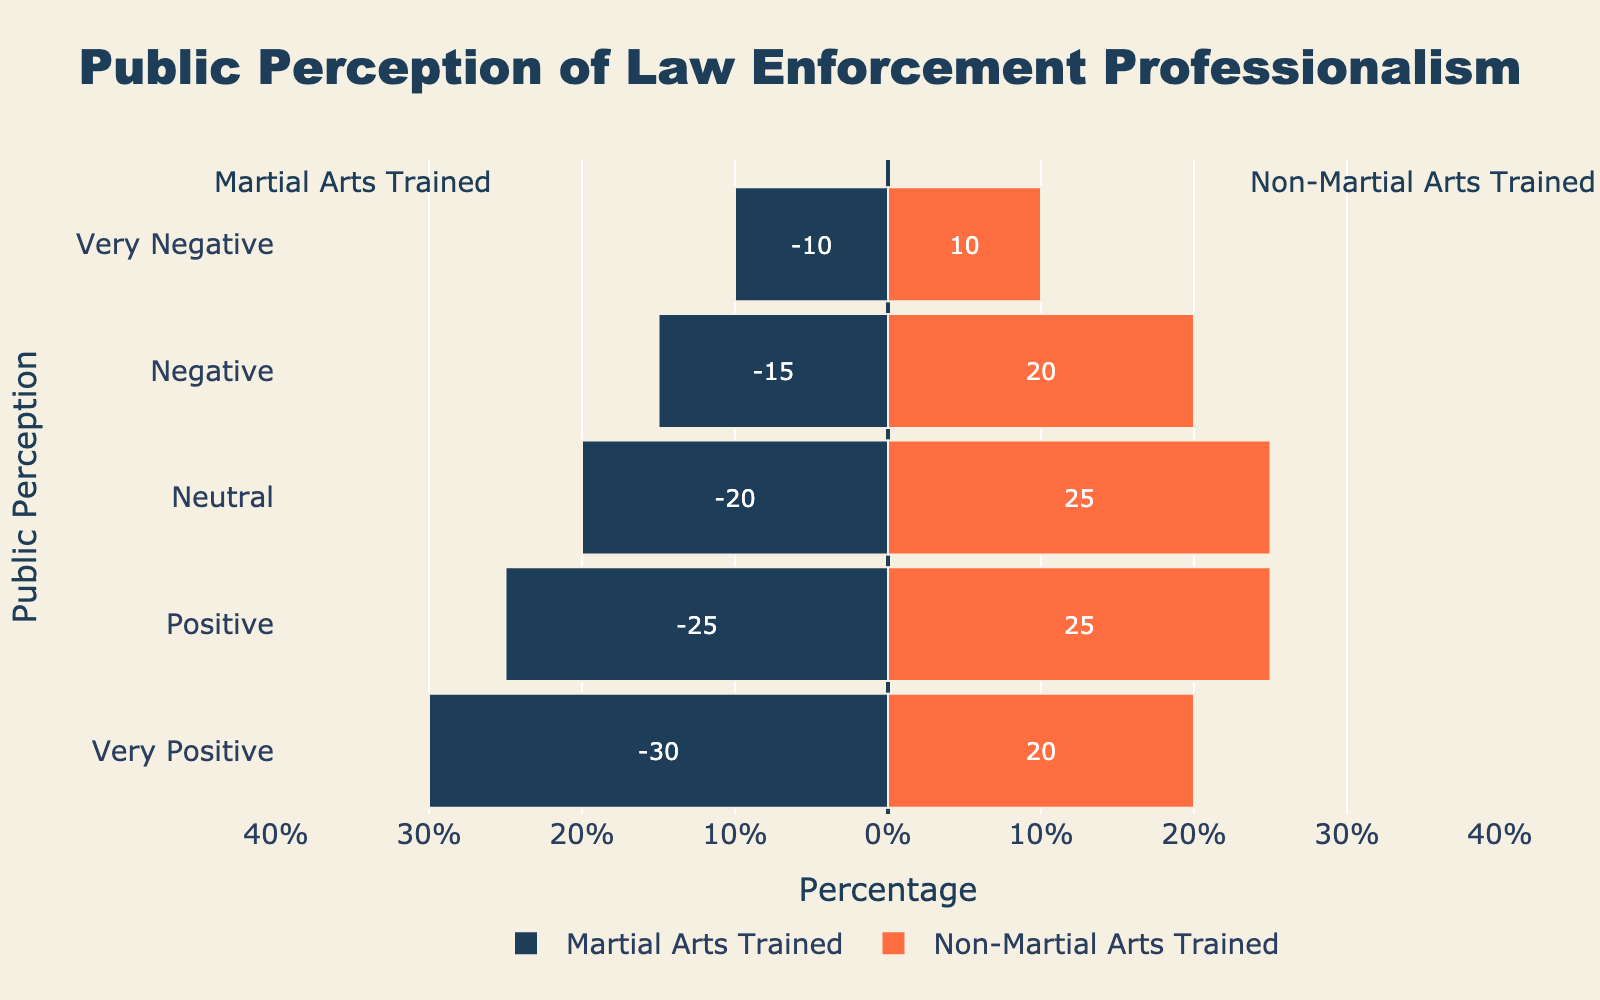What percentage of the public has a very positive perception of martial arts-trained officers? Locate the bar labeled "Very Positive" on the left side representing martial arts-trained officers and read the percentage, which is -30%. The negative sign indicates direction, and the actual percentage is 30%.
Answer: 30% How does the percentage of very positive perceptions compare between martial arts-trained and non-martial arts-trained officers? Compare the "Very Positive" categories. Martial arts-trained officers have 30%, and non-martial arts-trained officers have 20%.
Answer: Martial arts-trained officers have 10% more very positive perceptions What is the total percentage of positive and very positive perceptions for non-martial arts-trained officers? Add the percentages for "Positive" and "Very Positive" for non-martial arts-trained officers. Positive is 25% and Very Positive is 20%, so 25% + 20% = 45%.
Answer: 45% Is the percentage of negative perceptions higher for martial arts-trained officers or non-martial arts-trained officers? Compare the "Negative" categories. Martial arts-trained officers have 15%, and non-martial arts-trained officers have 20%.
Answer: Non-martial arts-trained officers have a higher percentage What is the difference between the percentage of neutral perceptions of martial arts-trained and non-martial arts-trained officers? Subtract the "Neutral" perception percentage for martial arts-trained officers from non-martial arts-trained officers. Both have 20%, so 25% - 20% = 0%.
Answer: 0% Looking at the positive perception categories (both Positive and Very Positive), which group has a higher combined percentage? Sum the percentages for "Positive" and "Very Positive" categories for both groups. 
Martial arts-trained: 30% (Very Positive) + 25% (Positive) = 55%. 
Non-martial arts-trained: 20% (Very Positive) + 25% (Positive) = 45%.
Answer: Martial arts-trained How does the percentage of very negative perceptions vary between martial arts-trained and non-martial arts-trained officers? Compare the "Very Negative" categories. Both groups have 10% for "Very Negative".
Answer: No variation Which group has a smaller percentage of negative perceptions? Compare the "Negative" categories for both groups: martial arts-trained officers have 15%, and non-martial arts-trained officers have 20%.
Answer: Martial arts-trained officers What is the sum of percentages for negative and very negative perceptions among non-martial arts-trained officers? Add the "Negative" and "Very Negative" perceptions for non-martial arts-trained officers. Negative is 20% and Very Negative is 10%, so 20% + 10% = 30%.
Answer: 30% What percentage of the public perceives martial arts-trained officers in a neutral light? Locate the "Neutral" category for martial arts-trained officers and read the percentage, which is 20%.
Answer: 20% 